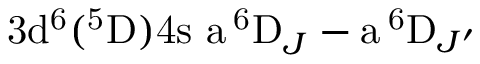Convert formula to latex. <formula><loc_0><loc_0><loc_500><loc_500>3 d ^ { 6 } ( ^ { 5 } D ) 4 s \ a \, ^ { 6 } D _ { J } - a \, ^ { 6 } D _ { J ^ { \prime } }</formula> 